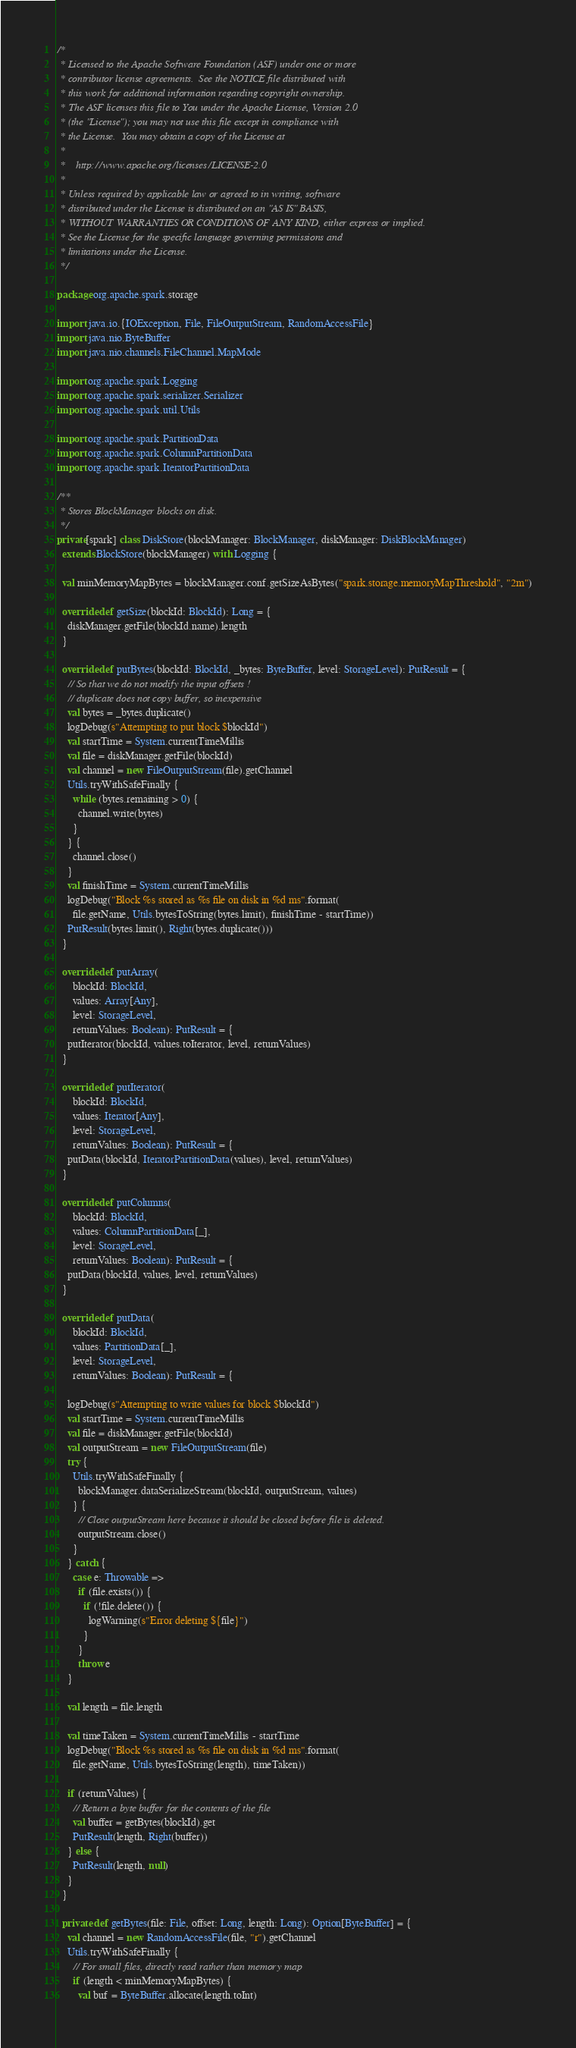<code> <loc_0><loc_0><loc_500><loc_500><_Scala_>/*
 * Licensed to the Apache Software Foundation (ASF) under one or more
 * contributor license agreements.  See the NOTICE file distributed with
 * this work for additional information regarding copyright ownership.
 * The ASF licenses this file to You under the Apache License, Version 2.0
 * (the "License"); you may not use this file except in compliance with
 * the License.  You may obtain a copy of the License at
 *
 *    http://www.apache.org/licenses/LICENSE-2.0
 *
 * Unless required by applicable law or agreed to in writing, software
 * distributed under the License is distributed on an "AS IS" BASIS,
 * WITHOUT WARRANTIES OR CONDITIONS OF ANY KIND, either express or implied.
 * See the License for the specific language governing permissions and
 * limitations under the License.
 */

package org.apache.spark.storage

import java.io.{IOException, File, FileOutputStream, RandomAccessFile}
import java.nio.ByteBuffer
import java.nio.channels.FileChannel.MapMode

import org.apache.spark.Logging
import org.apache.spark.serializer.Serializer
import org.apache.spark.util.Utils

import org.apache.spark.PartitionData
import org.apache.spark.ColumnPartitionData
import org.apache.spark.IteratorPartitionData

/**
 * Stores BlockManager blocks on disk.
 */
private[spark] class DiskStore(blockManager: BlockManager, diskManager: DiskBlockManager)
  extends BlockStore(blockManager) with Logging {

  val minMemoryMapBytes = blockManager.conf.getSizeAsBytes("spark.storage.memoryMapThreshold", "2m")

  override def getSize(blockId: BlockId): Long = {
    diskManager.getFile(blockId.name).length
  }

  override def putBytes(blockId: BlockId, _bytes: ByteBuffer, level: StorageLevel): PutResult = {
    // So that we do not modify the input offsets !
    // duplicate does not copy buffer, so inexpensive
    val bytes = _bytes.duplicate()
    logDebug(s"Attempting to put block $blockId")
    val startTime = System.currentTimeMillis
    val file = diskManager.getFile(blockId)
    val channel = new FileOutputStream(file).getChannel
    Utils.tryWithSafeFinally {
      while (bytes.remaining > 0) {
        channel.write(bytes)
      }
    } {
      channel.close()
    }
    val finishTime = System.currentTimeMillis
    logDebug("Block %s stored as %s file on disk in %d ms".format(
      file.getName, Utils.bytesToString(bytes.limit), finishTime - startTime))
    PutResult(bytes.limit(), Right(bytes.duplicate()))
  }

  override def putArray(
      blockId: BlockId,
      values: Array[Any],
      level: StorageLevel,
      returnValues: Boolean): PutResult = {
    putIterator(blockId, values.toIterator, level, returnValues)
  }

  override def putIterator(
      blockId: BlockId,
      values: Iterator[Any],
      level: StorageLevel,
      returnValues: Boolean): PutResult = {
    putData(blockId, IteratorPartitionData(values), level, returnValues)
  }

  override def putColumns(
      blockId: BlockId,
      values: ColumnPartitionData[_],
      level: StorageLevel,
      returnValues: Boolean): PutResult = {
    putData(blockId, values, level, returnValues)
  }

  override def putData(
      blockId: BlockId,
      values: PartitionData[_],
      level: StorageLevel,
      returnValues: Boolean): PutResult = {

    logDebug(s"Attempting to write values for block $blockId")
    val startTime = System.currentTimeMillis
    val file = diskManager.getFile(blockId)
    val outputStream = new FileOutputStream(file)
    try {
      Utils.tryWithSafeFinally {
        blockManager.dataSerializeStream(blockId, outputStream, values)
      } {
        // Close outputStream here because it should be closed before file is deleted.
        outputStream.close()
      }
    } catch {
      case e: Throwable =>
        if (file.exists()) {
          if (!file.delete()) {
            logWarning(s"Error deleting ${file}")
          }
        }
        throw e
    }

    val length = file.length

    val timeTaken = System.currentTimeMillis - startTime
    logDebug("Block %s stored as %s file on disk in %d ms".format(
      file.getName, Utils.bytesToString(length), timeTaken))

    if (returnValues) {
      // Return a byte buffer for the contents of the file
      val buffer = getBytes(blockId).get
      PutResult(length, Right(buffer))
    } else {
      PutResult(length, null)
    }
  }

  private def getBytes(file: File, offset: Long, length: Long): Option[ByteBuffer] = {
    val channel = new RandomAccessFile(file, "r").getChannel
    Utils.tryWithSafeFinally {
      // For small files, directly read rather than memory map
      if (length < minMemoryMapBytes) {
        val buf = ByteBuffer.allocate(length.toInt)</code> 